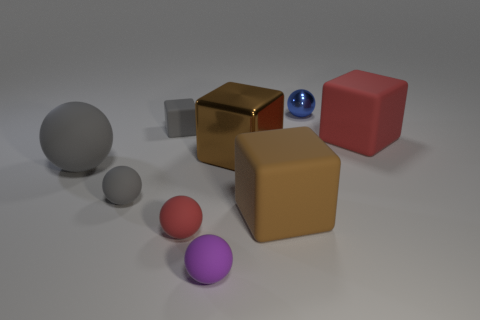Subtract all green spheres. Subtract all red cubes. How many spheres are left? 5 Subtract all yellow cylinders. How many red cubes are left? 1 Add 4 reds. How many tiny blues exist? 0 Subtract all large yellow shiny balls. Subtract all blocks. How many objects are left? 5 Add 5 small matte blocks. How many small matte blocks are left? 6 Add 8 large red rubber balls. How many large red rubber balls exist? 8 Add 1 small yellow matte things. How many objects exist? 10 Subtract all red balls. How many balls are left? 4 Subtract all tiny blue shiny spheres. How many spheres are left? 4 Subtract 0 yellow cubes. How many objects are left? 9 